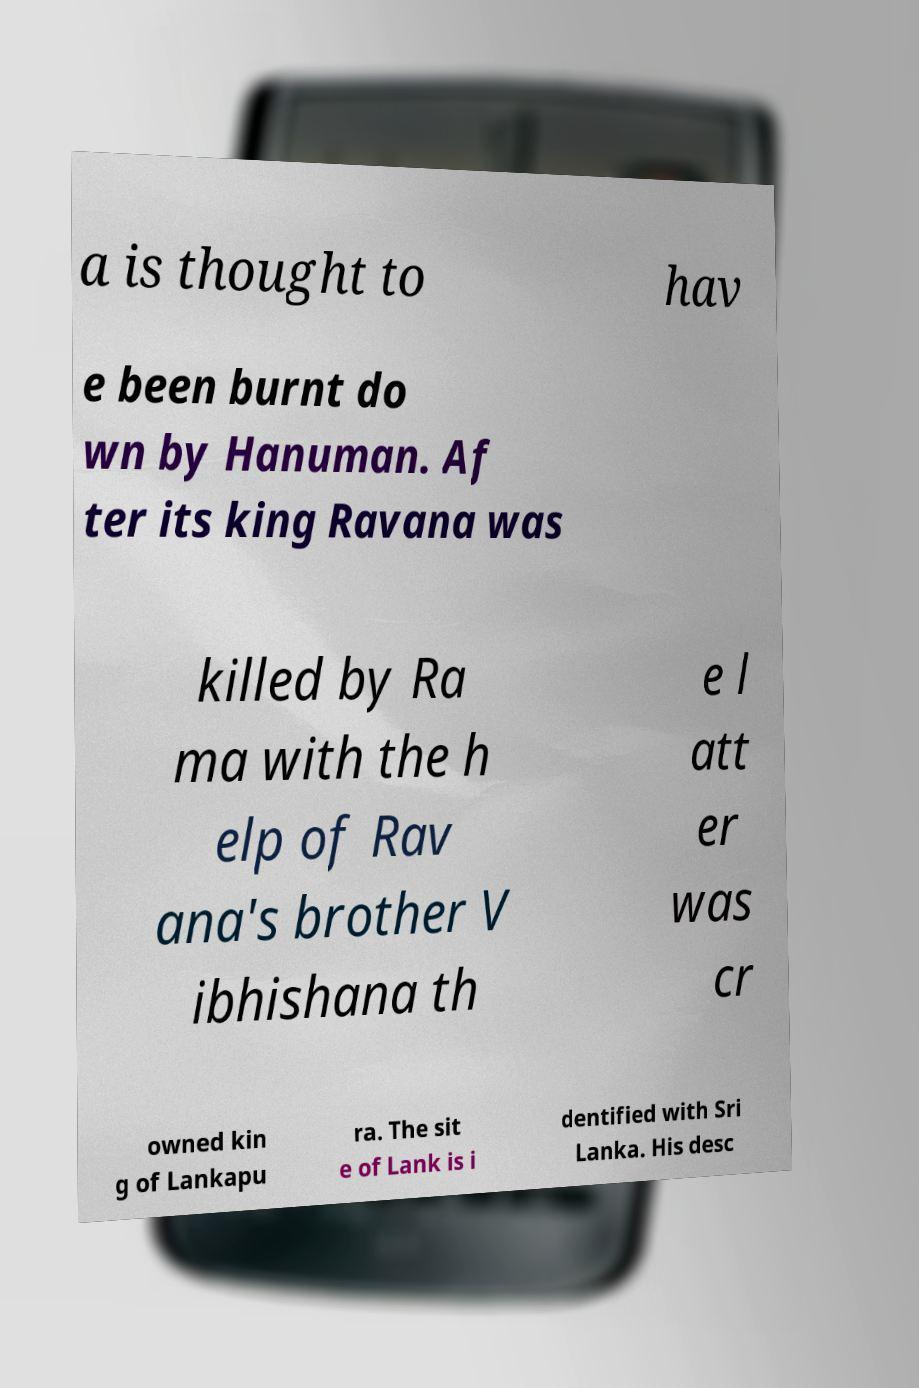Can you accurately transcribe the text from the provided image for me? a is thought to hav e been burnt do wn by Hanuman. Af ter its king Ravana was killed by Ra ma with the h elp of Rav ana's brother V ibhishana th e l att er was cr owned kin g of Lankapu ra. The sit e of Lank is i dentified with Sri Lanka. His desc 